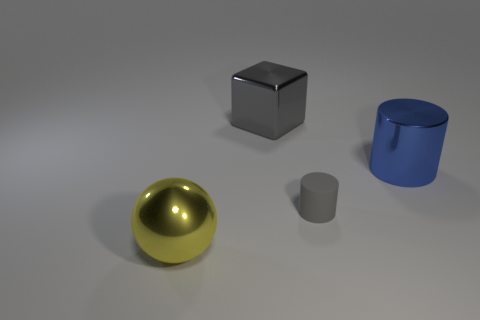What number of other things are there of the same color as the big metal sphere?
Your answer should be very brief. 0. There is a large object that is in front of the gray thing that is in front of the large gray metallic object; what shape is it?
Give a very brief answer. Sphere. There is a big blue thing; what number of big blue metal cylinders are behind it?
Your answer should be very brief. 0. Is there a tiny purple thing that has the same material as the blue cylinder?
Provide a succinct answer. No. What material is the gray thing that is the same size as the blue metal object?
Your response must be concise. Metal. There is a object that is both on the right side of the big gray object and behind the small gray rubber cylinder; what is its size?
Keep it short and to the point. Large. What is the color of the large metal thing that is both on the left side of the blue metal cylinder and right of the large yellow metallic object?
Your response must be concise. Gray. Is the number of small matte things that are behind the gray cylinder less than the number of big gray metal objects right of the yellow metal sphere?
Offer a very short reply. Yes. What number of large metal things are the same shape as the small thing?
Provide a succinct answer. 1. What size is the blue object that is the same material as the large ball?
Offer a very short reply. Large. 